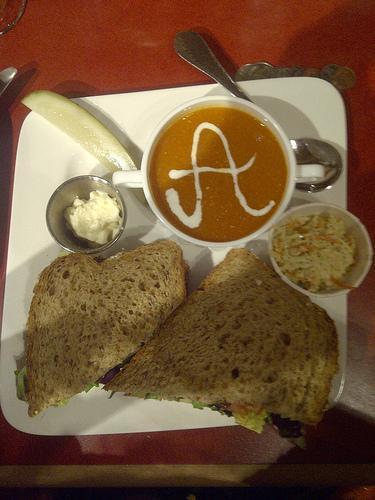How many spoons are there?
Give a very brief answer. 1. 